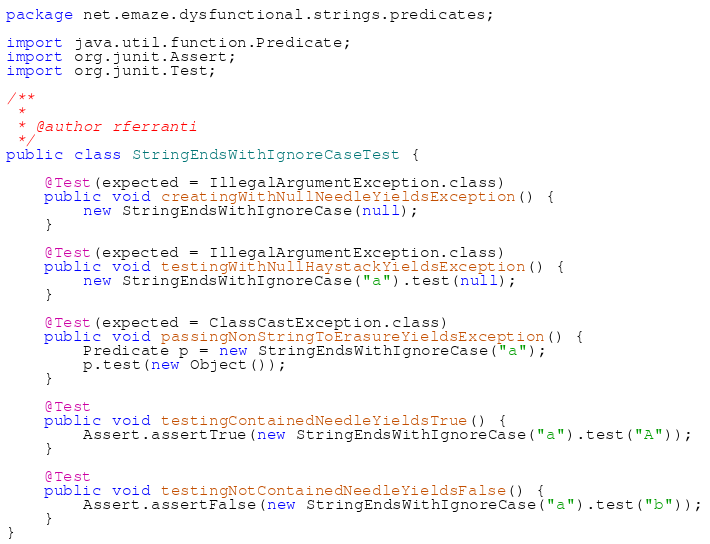Convert code to text. <code><loc_0><loc_0><loc_500><loc_500><_Java_>package net.emaze.dysfunctional.strings.predicates;

import java.util.function.Predicate;
import org.junit.Assert;
import org.junit.Test;

/**
 *
 * @author rferranti
 */
public class StringEndsWithIgnoreCaseTest {

    @Test(expected = IllegalArgumentException.class)
    public void creatingWithNullNeedleYieldsException() {
        new StringEndsWithIgnoreCase(null);
    }

    @Test(expected = IllegalArgumentException.class)
    public void testingWithNullHaystackYieldsException() {
        new StringEndsWithIgnoreCase("a").test(null);
    }
    
    @Test(expected = ClassCastException.class)
    public void passingNonStringToErasureYieldsException() {
        Predicate p = new StringEndsWithIgnoreCase("a");
        p.test(new Object());
    }    

    @Test
    public void testingContainedNeedleYieldsTrue() {
        Assert.assertTrue(new StringEndsWithIgnoreCase("a").test("A"));
    }

    @Test
    public void testingNotContainedNeedleYieldsFalse() {
        Assert.assertFalse(new StringEndsWithIgnoreCase("a").test("b"));
    }
}</code> 